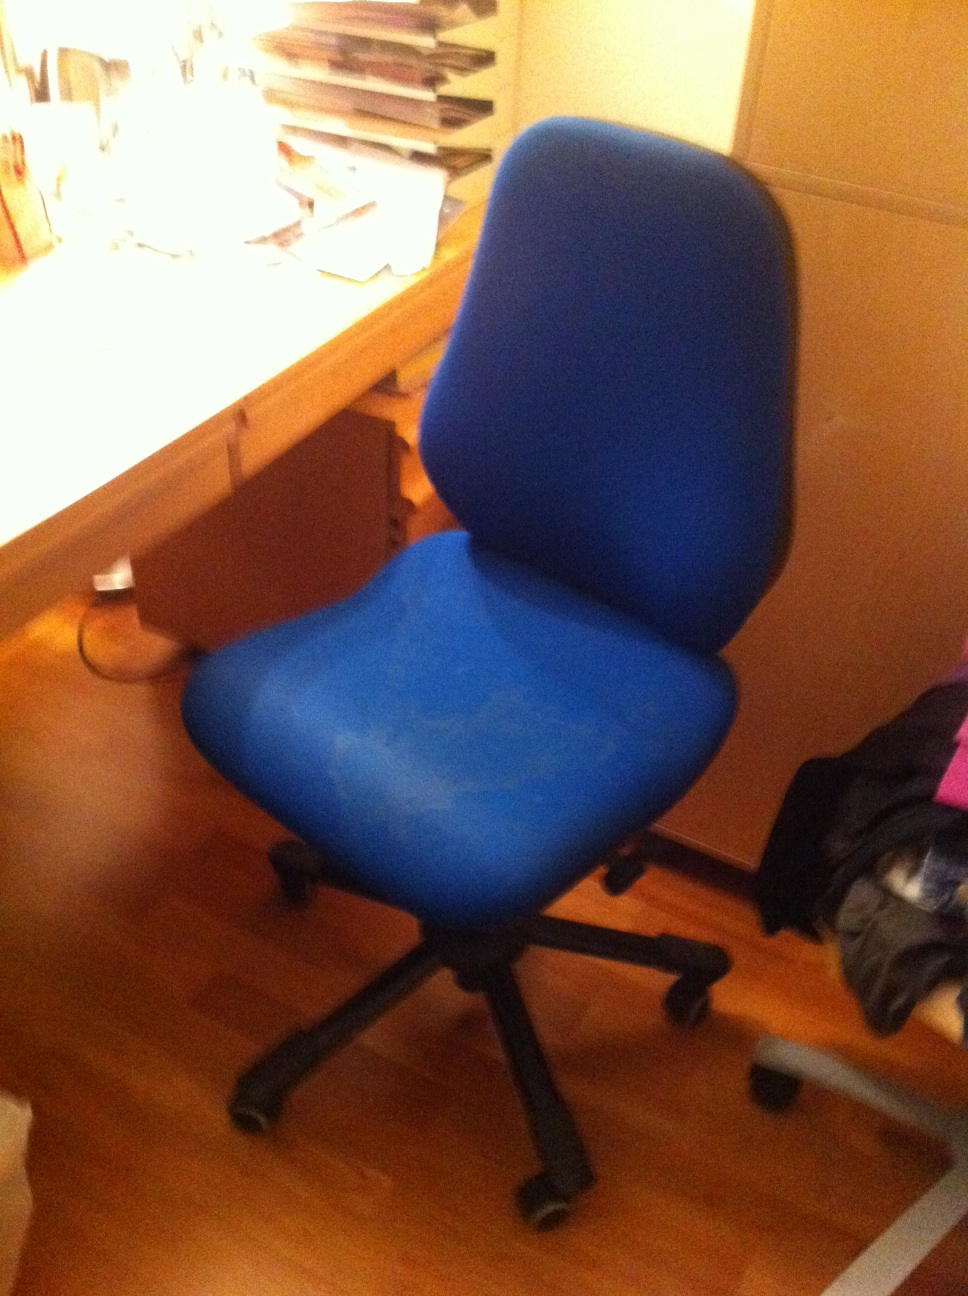What is this? This is a blue office chair with a cushioned seat and backrest. It has a wheeled base, which allows for easy movement across the room. The chair is positioned beside a wooden desk with various items on top, including paperwork and a lamp. 